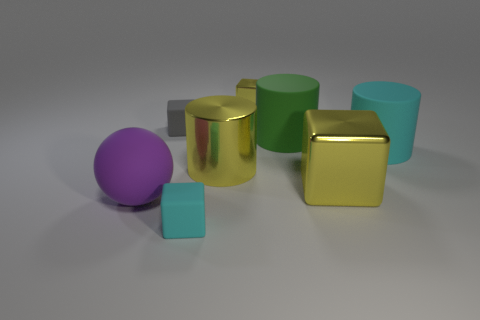Describe the color palette used in this image. The color palette of this image is quite varied but harmonious, featuring cool tones such as greens and blues, complemented by a warm, golden hue. The purple of the sphere adds a pop of contrast to the scene. How does the use of color affect the mood or atmosphere of the image? The cool colors evoke a serene and calm atmosphere, while the addition of the warm gold adds an element of luxury or value to the scene. The purple sphere provides a vibrant contrast that draws attention and adds depth to the color story. 